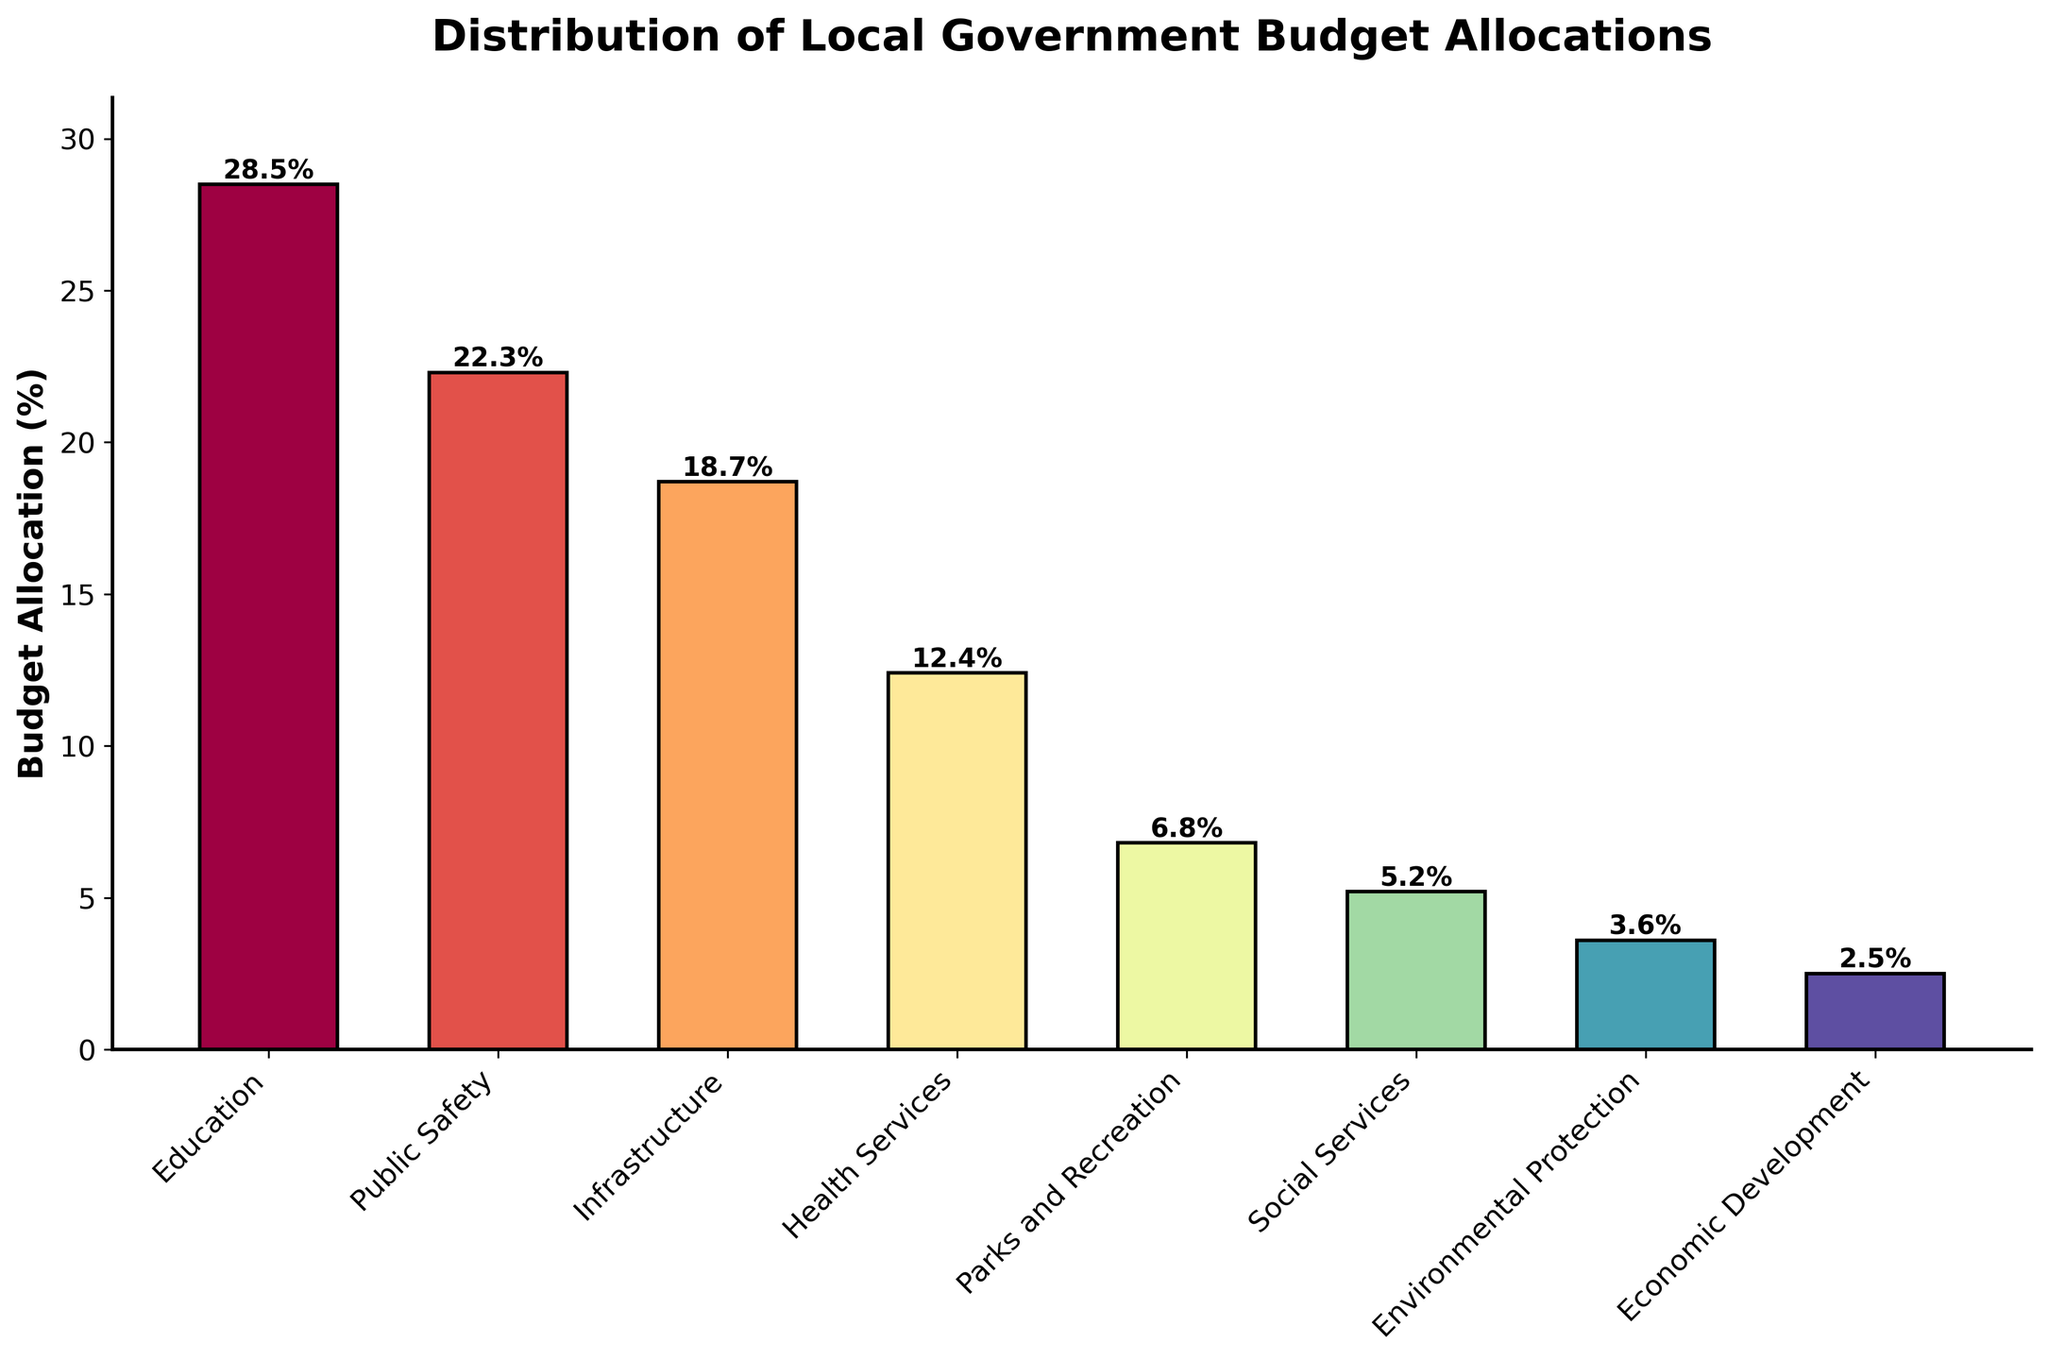What sector receives the highest budget allocation? The tallest bar represents the sector with the highest percentage. The bar for "Education" is the highest.
Answer: Education Which sector has the lowest budget allocation? The shortest bar represents the sector with the lowest percentage. The bar for "Economic Development" is the shortest.
Answer: Economic Development How much more budget allocation does Public Safety receive compared to Social Services? Identify the bars for "Public Safety" and "Social Services," then subtract the percentage of Social Services from Public Safety: 22.3% - 5.2% = 17.1%.
Answer: 17.1% What is the total budget allocation for Infrastructure, Parks and Recreation, and Economic Development combined? Sum the percentages for each sector: 18.7% + 6.8% + 2.5% = 28.0%.
Answer: 28.0% Which sectors have a budget allocation greater than 20%? Identify and list the sectors with bars higher than 20%: "Education" and "Public Safety."
Answer: Education, Public Safety How does the budget allocation for Health Services compare to that for Parks and Recreation? The bar for "Health Services" (12.4%) is taller than the bar for "Parks and Recreation" (6.8%).
Answer: Health Services receives more What is the average budget allocation for Education and Public Safety? Sum the percentages of Education and Public Safety and divide by 2: (28.5% + 22.3%)/2 = 25.4%.
Answer: 25.4% How much budget allocation would remain if Education and Public Safety allocations were removed? Subtract the sum of Education and Public Safety from 100%: 100% - (28.5% + 22.3%) = 49.2%.
Answer: 49.2% Which sector has the median budget allocation? Arrange the sectors in descending order and find the middle value. The middle value is Parks and Recreation.
Answer: Parks and Recreation Is there a sector with exactly half the budget allocation of Education? Half of Education’s 28.5% is 14.25%; none of the bars represent this exact percentage.
Answer: No 